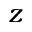<formula> <loc_0><loc_0><loc_500><loc_500>z</formula> 